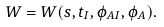<formula> <loc_0><loc_0><loc_500><loc_500>W = W ( s , t _ { I } , \phi _ { A I } , \phi _ { A } ) .</formula> 